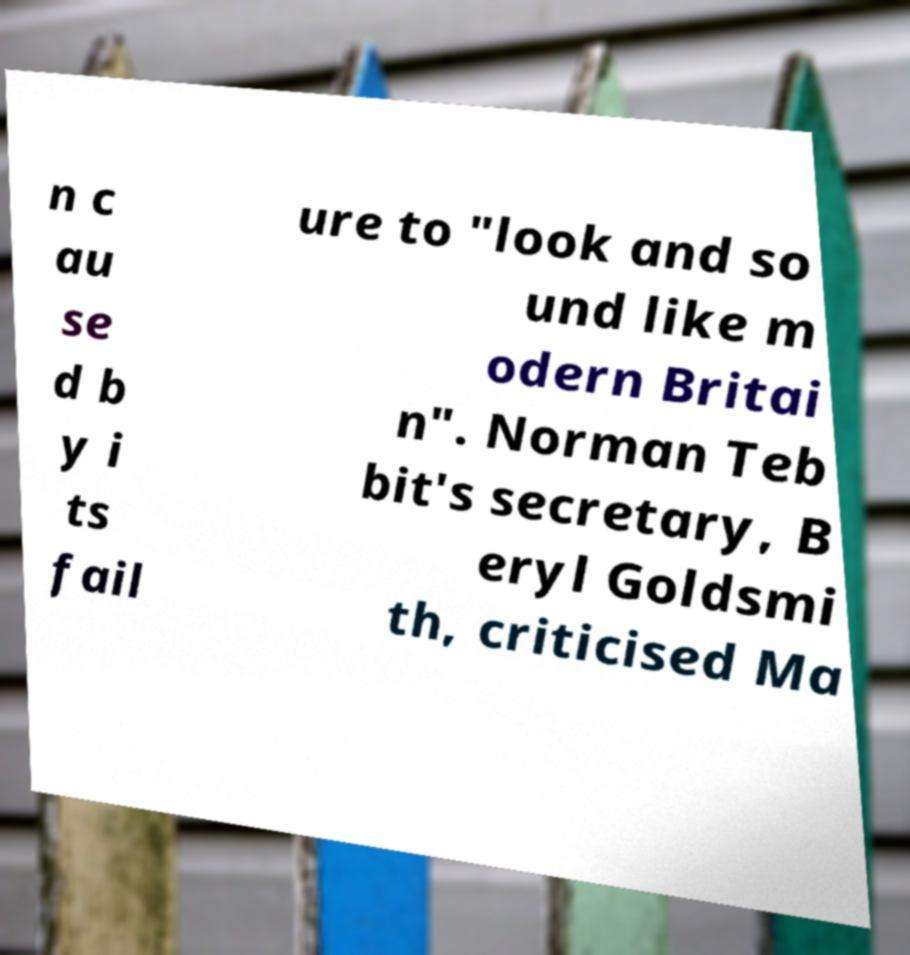For documentation purposes, I need the text within this image transcribed. Could you provide that? n c au se d b y i ts fail ure to "look and so und like m odern Britai n". Norman Teb bit's secretary, B eryl Goldsmi th, criticised Ma 